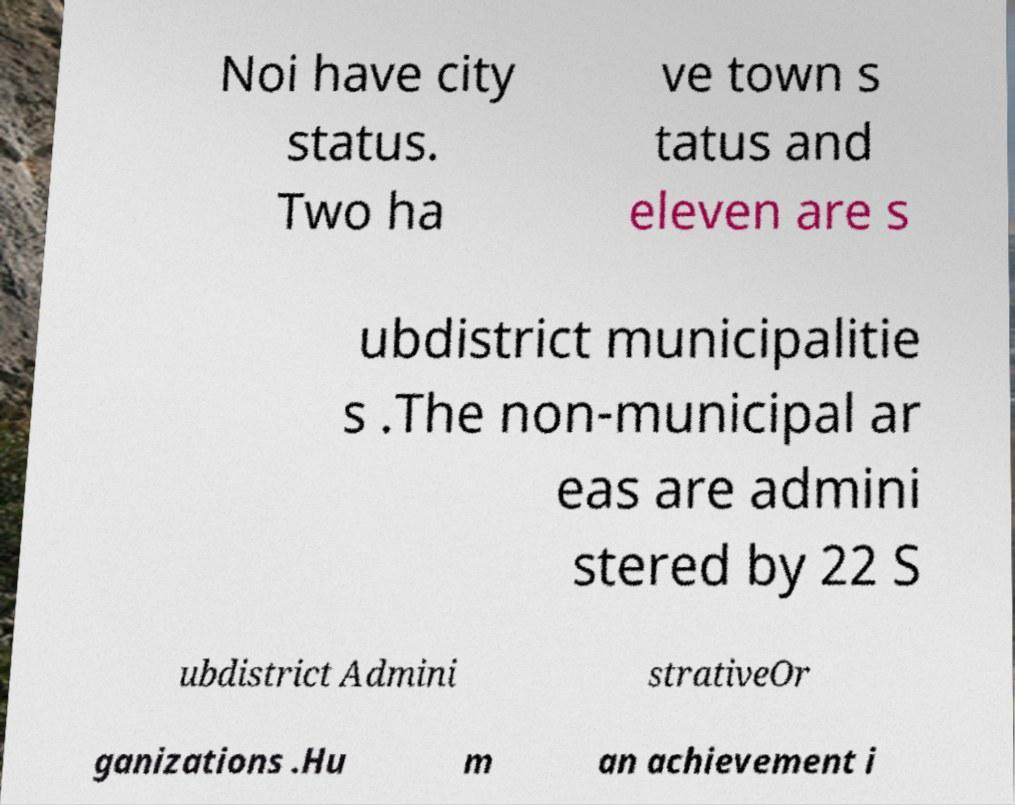Could you extract and type out the text from this image? Noi have city status. Two ha ve town s tatus and eleven are s ubdistrict municipalitie s .The non-municipal ar eas are admini stered by 22 S ubdistrict Admini strativeOr ganizations .Hu m an achievement i 